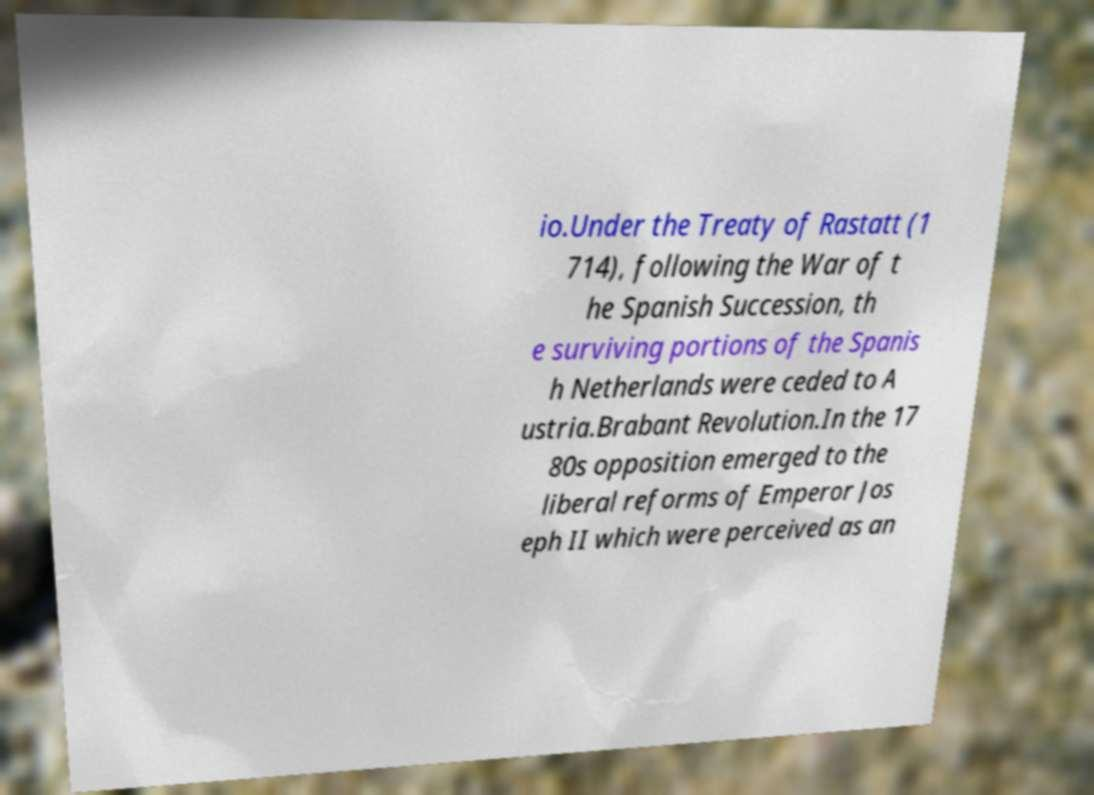Please read and relay the text visible in this image. What does it say? io.Under the Treaty of Rastatt (1 714), following the War of t he Spanish Succession, th e surviving portions of the Spanis h Netherlands were ceded to A ustria.Brabant Revolution.In the 17 80s opposition emerged to the liberal reforms of Emperor Jos eph II which were perceived as an 